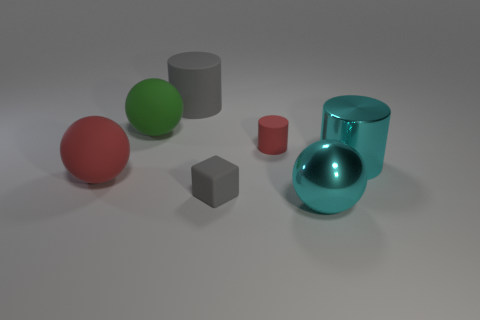There is a large metallic thing that is the same shape as the large green rubber object; what is its color?
Provide a succinct answer. Cyan. Is there anything else that is the same color as the cube?
Provide a short and direct response. Yes. There is a big thing to the right of the large cyan shiny thing in front of the red matte ball on the left side of the large gray thing; what is its shape?
Your answer should be compact. Cylinder. There is a rubber cylinder that is right of the small gray rubber thing; is its size the same as the cyan object in front of the small gray matte thing?
Keep it short and to the point. No. What number of other gray cubes have the same material as the tiny gray cube?
Your response must be concise. 0. Is the number of tiny red cylinders the same as the number of objects?
Make the answer very short. No. There is a matte cylinder that is to the right of the small object in front of the red cylinder; how many small things are behind it?
Keep it short and to the point. 0. Does the big red object have the same shape as the green thing?
Your answer should be very brief. Yes. Are there any big purple objects that have the same shape as the small gray rubber thing?
Offer a very short reply. No. The red thing that is the same size as the green matte thing is what shape?
Offer a terse response. Sphere. 